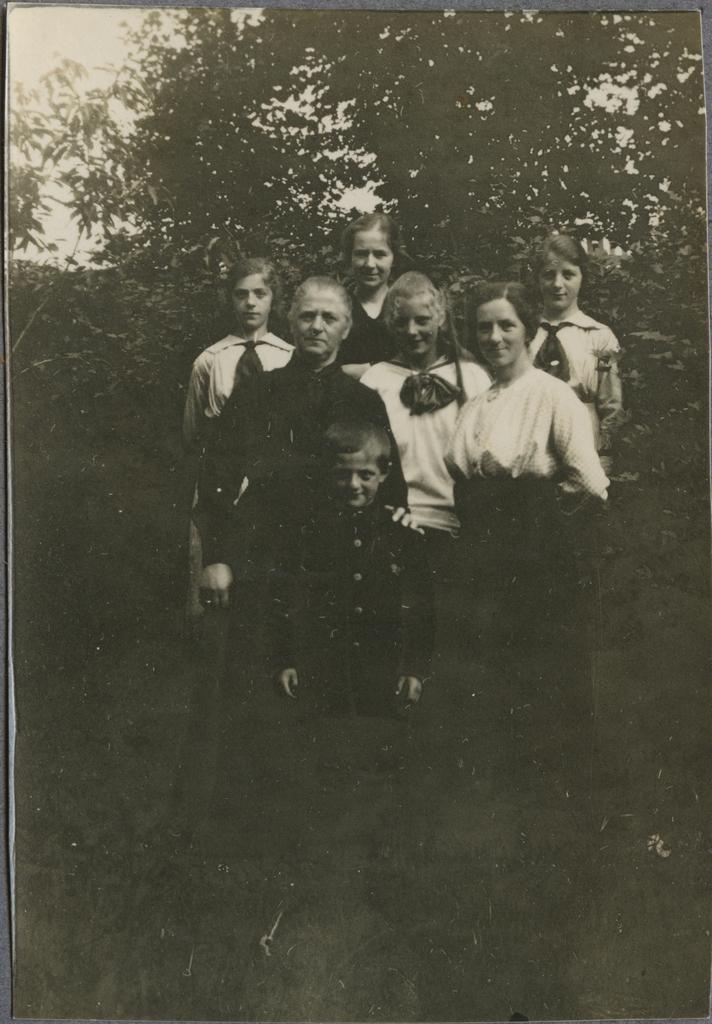Could you give a brief overview of what you see in this image? This is a black and white image , where there are group of people standing and smiling , trees, and in the background there is sky. 